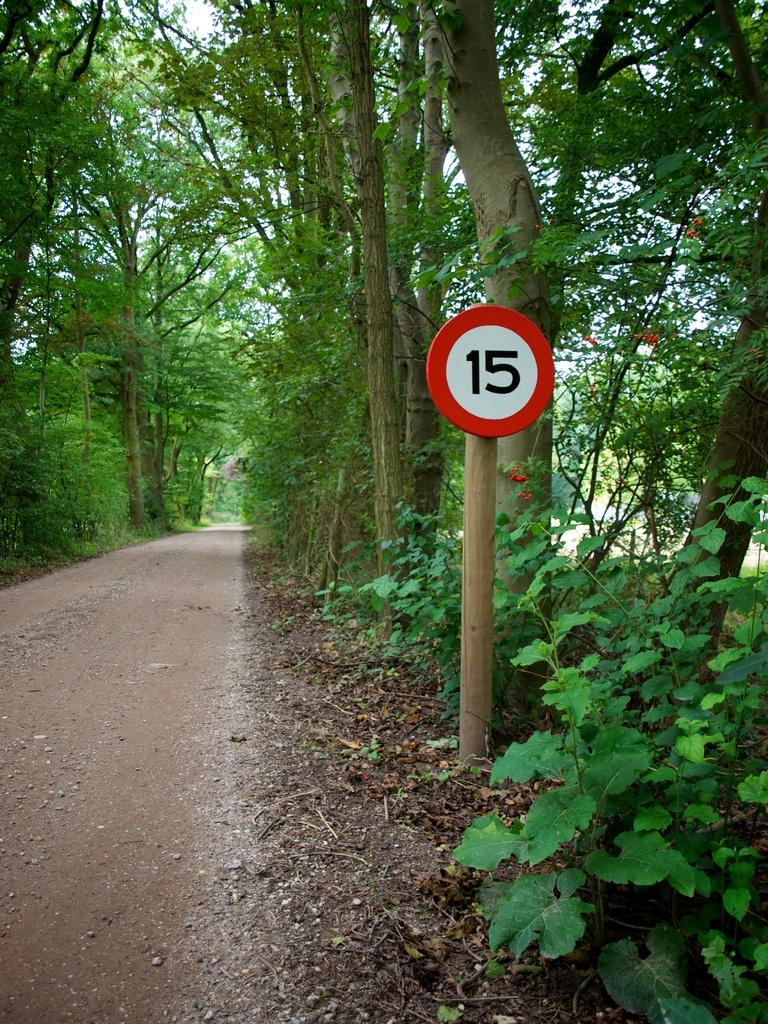<image>
Write a terse but informative summary of the picture. A red and white marker 15 on a tree lined path. 